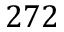Convert formula to latex. <formula><loc_0><loc_0><loc_500><loc_500>2 7 2</formula> 